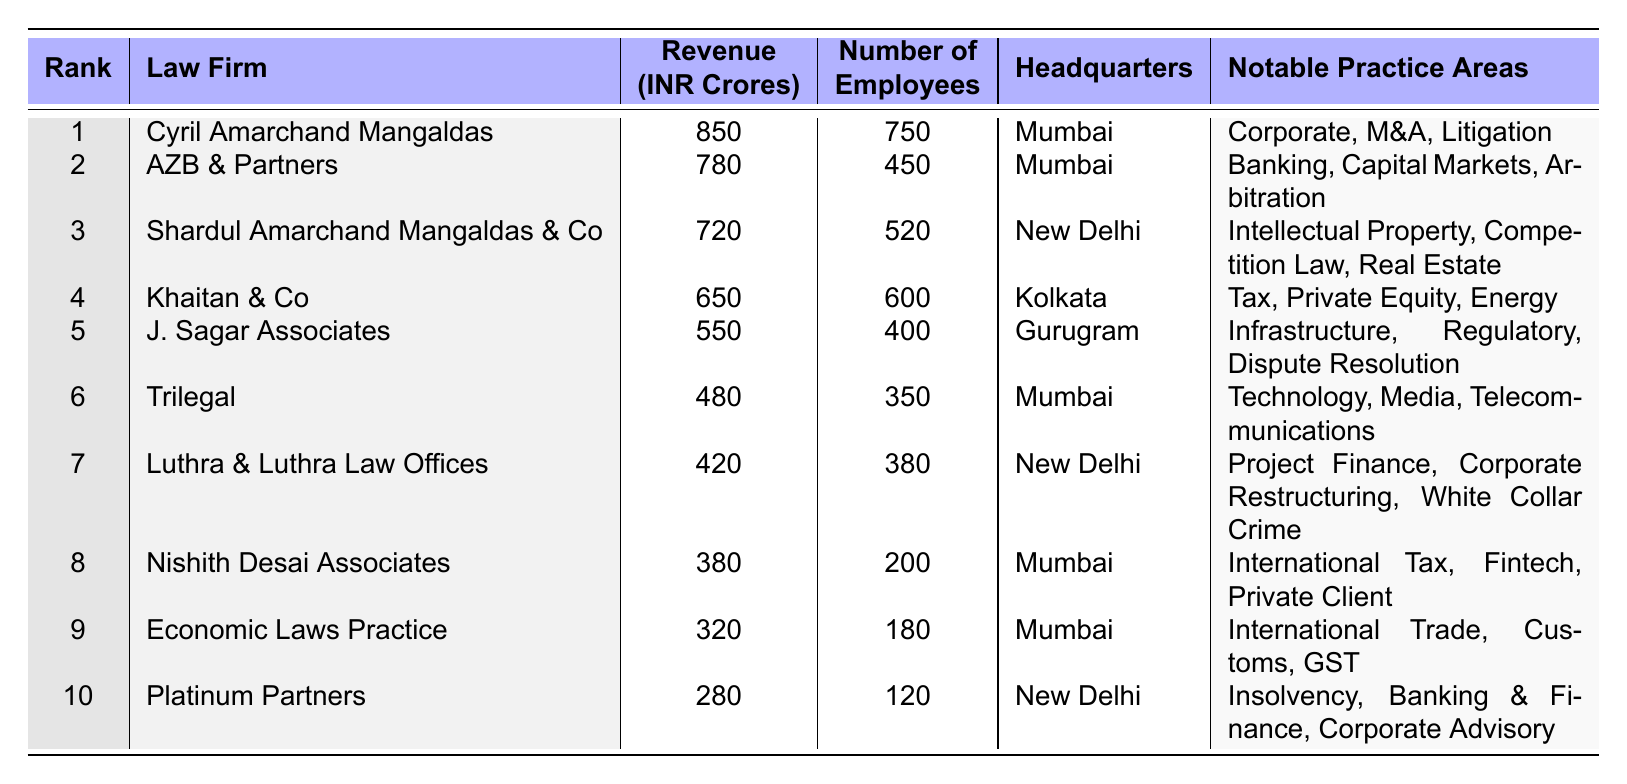What is the revenue of Cyril Amarchand Mangaldas? The table indicates that Cyril Amarchand Mangaldas has a revenue of 850 INR Crores.
Answer: 850 INR Crores Which law firm has the highest number of employees? By checking the "Number of Employees" column, Cyril Amarchand Mangaldas has the highest number with 750 employees.
Answer: Cyril Amarchand Mangaldas What is the average revenue of the top three law firms? The revenues of the top three firms are 850, 780, and 720. Adding these gives 850 + 780 + 720 = 2350, and dividing by 3 results in 2350 / 3 = 783.33.
Answer: 783.33 INR Crores Does AZB & Partners have more revenue than Khaitan & Co? AZB & Partners has a revenue of 780 INR Crores, while Khaitan & Co has 650 INR Crores. Therefore, AZB & Partners does have more revenue.
Answer: Yes How many law firms have a revenue greater than 500 INR Crores? The firms with revenue greater than 500 are Cyril Amarchand Mangaldas, AZB & Partners, Shardul Amarchand Mangaldas & Co, Khaitan & Co, and J. Sagar Associates. That totals 5 firms.
Answer: 5 What is the combined revenue of the bottom three law firms? The revenues of the bottom three firms are 420, 380, and 320. Their combined revenue is 420 + 380 + 320 = 1120 INR Crores.
Answer: 1120 INR Crores Is the headquarters of Nishith Desai Associates located in Mumbai? The table shows that Nishith Desai Associates is headquartered in Mumbai.
Answer: Yes Which law firm has the least number of employees, and what is that number? The table indicates that Platinum Partners has the least number of employees, totaling 120.
Answer: Platinum Partners, 120 What is the difference in revenue between the top-ranked and the bottom-ranked law firm? The top-ranked firm, Cyril Amarchand Mangaldas has a revenue of 850, while the bottom-ranked firm, Platinum Partners, has 280. The difference is 850 - 280 = 570.
Answer: 570 INR Crores Which firm ranked fifth has its headquarters in Gurugram? The table shows that J. Sagar Associates is the fifth-ranked firm and is headquartered in Gurugram.
Answer: J. Sagar Associates 